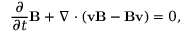Convert formula to latex. <formula><loc_0><loc_0><loc_500><loc_500>\frac { \partial } { \partial t } B + \nabla \cdot ( v B - B v ) = 0 ,</formula> 